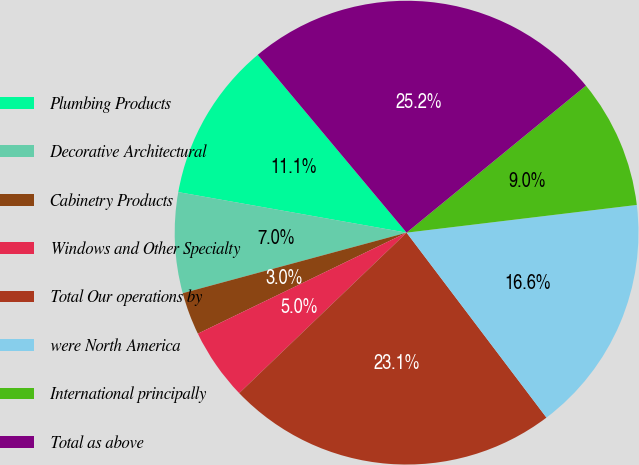Convert chart. <chart><loc_0><loc_0><loc_500><loc_500><pie_chart><fcel>Plumbing Products<fcel>Decorative Architectural<fcel>Cabinetry Products<fcel>Windows and Other Specialty<fcel>Total Our operations by<fcel>were North America<fcel>International principally<fcel>Total as above<nl><fcel>11.11%<fcel>7.0%<fcel>2.97%<fcel>4.99%<fcel>23.14%<fcel>16.6%<fcel>9.02%<fcel>25.16%<nl></chart> 